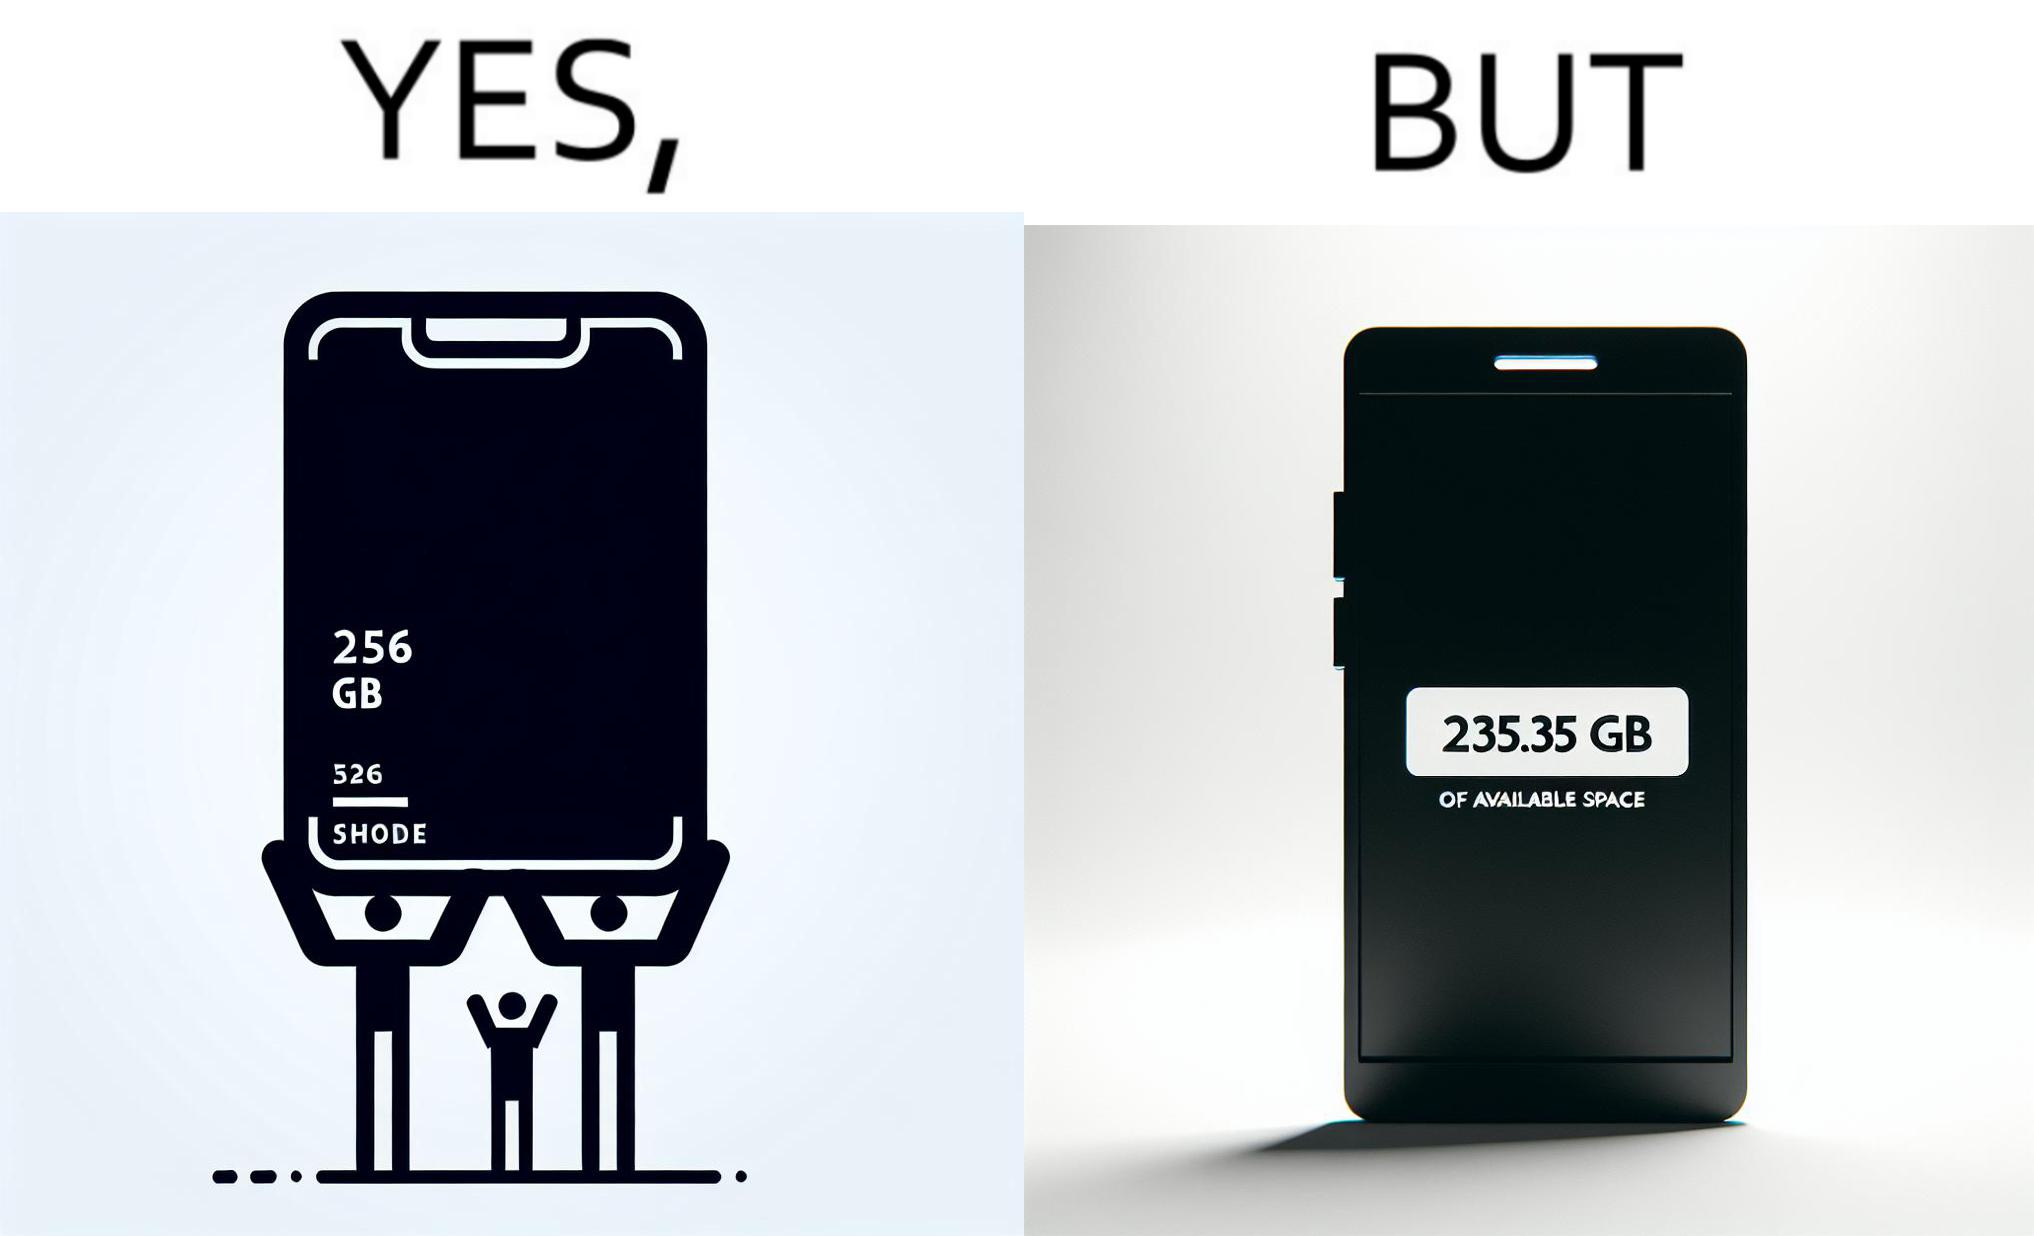Describe the satirical element in this image. The images are funny since they show how smartphone manufacturers advertise their smartphones to have a high internal storage space but in reality, the amount of space available to an user is considerably less due to pre-installed software 